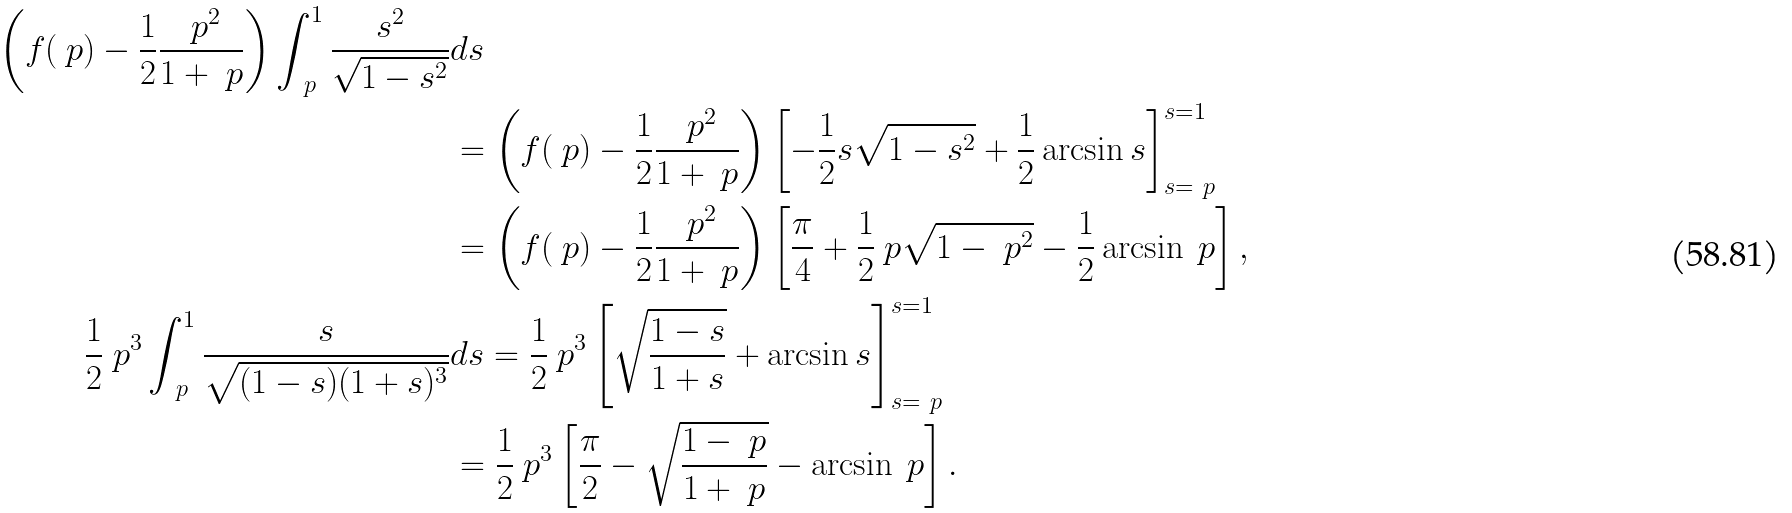<formula> <loc_0><loc_0><loc_500><loc_500>\left ( f ( \ p ) - \frac { 1 } { 2 } \frac { \ p ^ { 2 } } { 1 + \ p } \right ) \int _ { \ p } ^ { 1 } \frac { s ^ { 2 } } { \sqrt { 1 - s ^ { 2 } } } & d s \\ & = \left ( f ( \ p ) - \frac { 1 } { 2 } \frac { \ p ^ { 2 } } { 1 + \ p } \right ) \left [ - \frac { 1 } { 2 } s \sqrt { 1 - s ^ { 2 } } + \frac { 1 } { 2 } \arcsin s \right ] _ { s = \ p } ^ { s = 1 } \\ & = \left ( f ( \ p ) - \frac { 1 } { 2 } \frac { \ p ^ { 2 } } { 1 + \ p } \right ) \left [ \frac { \pi } { 4 } + \frac { 1 } { 2 } \ p \sqrt { 1 - \ p ^ { 2 } } - \frac { 1 } { 2 } \arcsin \ p \right ] , \\ \frac { 1 } { 2 } \ p ^ { 3 } \int _ { \ p } ^ { 1 } \frac { s } { \sqrt { ( 1 - s ) ( 1 + s ) ^ { 3 } } } & d s = \frac { 1 } { 2 } \ p ^ { 3 } \left [ \sqrt { \frac { 1 - s } { 1 + s } } + \arcsin s \right ] _ { s = \ p } ^ { s = 1 } \\ & = \frac { 1 } { 2 } \ p ^ { 3 } \left [ \frac { \pi } { 2 } - \sqrt { \frac { 1 - \ p } { 1 + \ p } } - \arcsin \ p \right ] .</formula> 